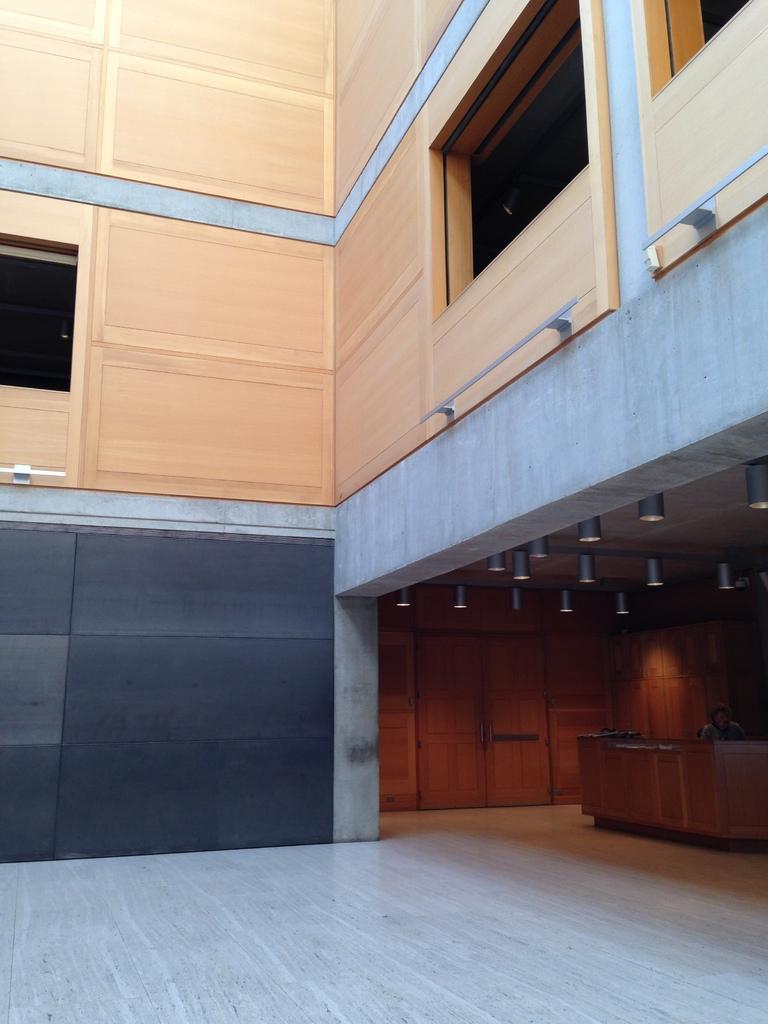Please provide a concise description of this image. In this image we can see wooden wall, glass windows, lights, door, desk and a person. 